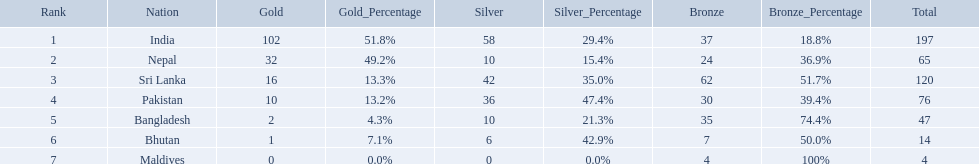Which countries won medals? India, Nepal, Sri Lanka, Pakistan, Bangladesh, Bhutan, Maldives. Which won the most? India. Which won the fewest? Maldives. What are the totals of medals one in each country? 197, 65, 120, 76, 47, 14, 4. Which of these totals are less than 10? 4. Who won this number of medals? Maldives. What were the total amount won of medals by nations in the 1999 south asian games? 197, 65, 120, 76, 47, 14, 4. Which amount was the lowest? 4. Which nation had this amount? Maldives. What nations took part in 1999 south asian games? India, Nepal, Sri Lanka, Pakistan, Bangladesh, Bhutan, Maldives. Of those who earned gold medals? India, Nepal, Sri Lanka, Pakistan, Bangladesh, Bhutan. Which nation didn't earn any gold medals? Maldives. What are all the countries listed in the table? India, Nepal, Sri Lanka, Pakistan, Bangladesh, Bhutan, Maldives. Which of these is not india? Nepal, Sri Lanka, Pakistan, Bangladesh, Bhutan, Maldives. Of these, which is first? Nepal. 